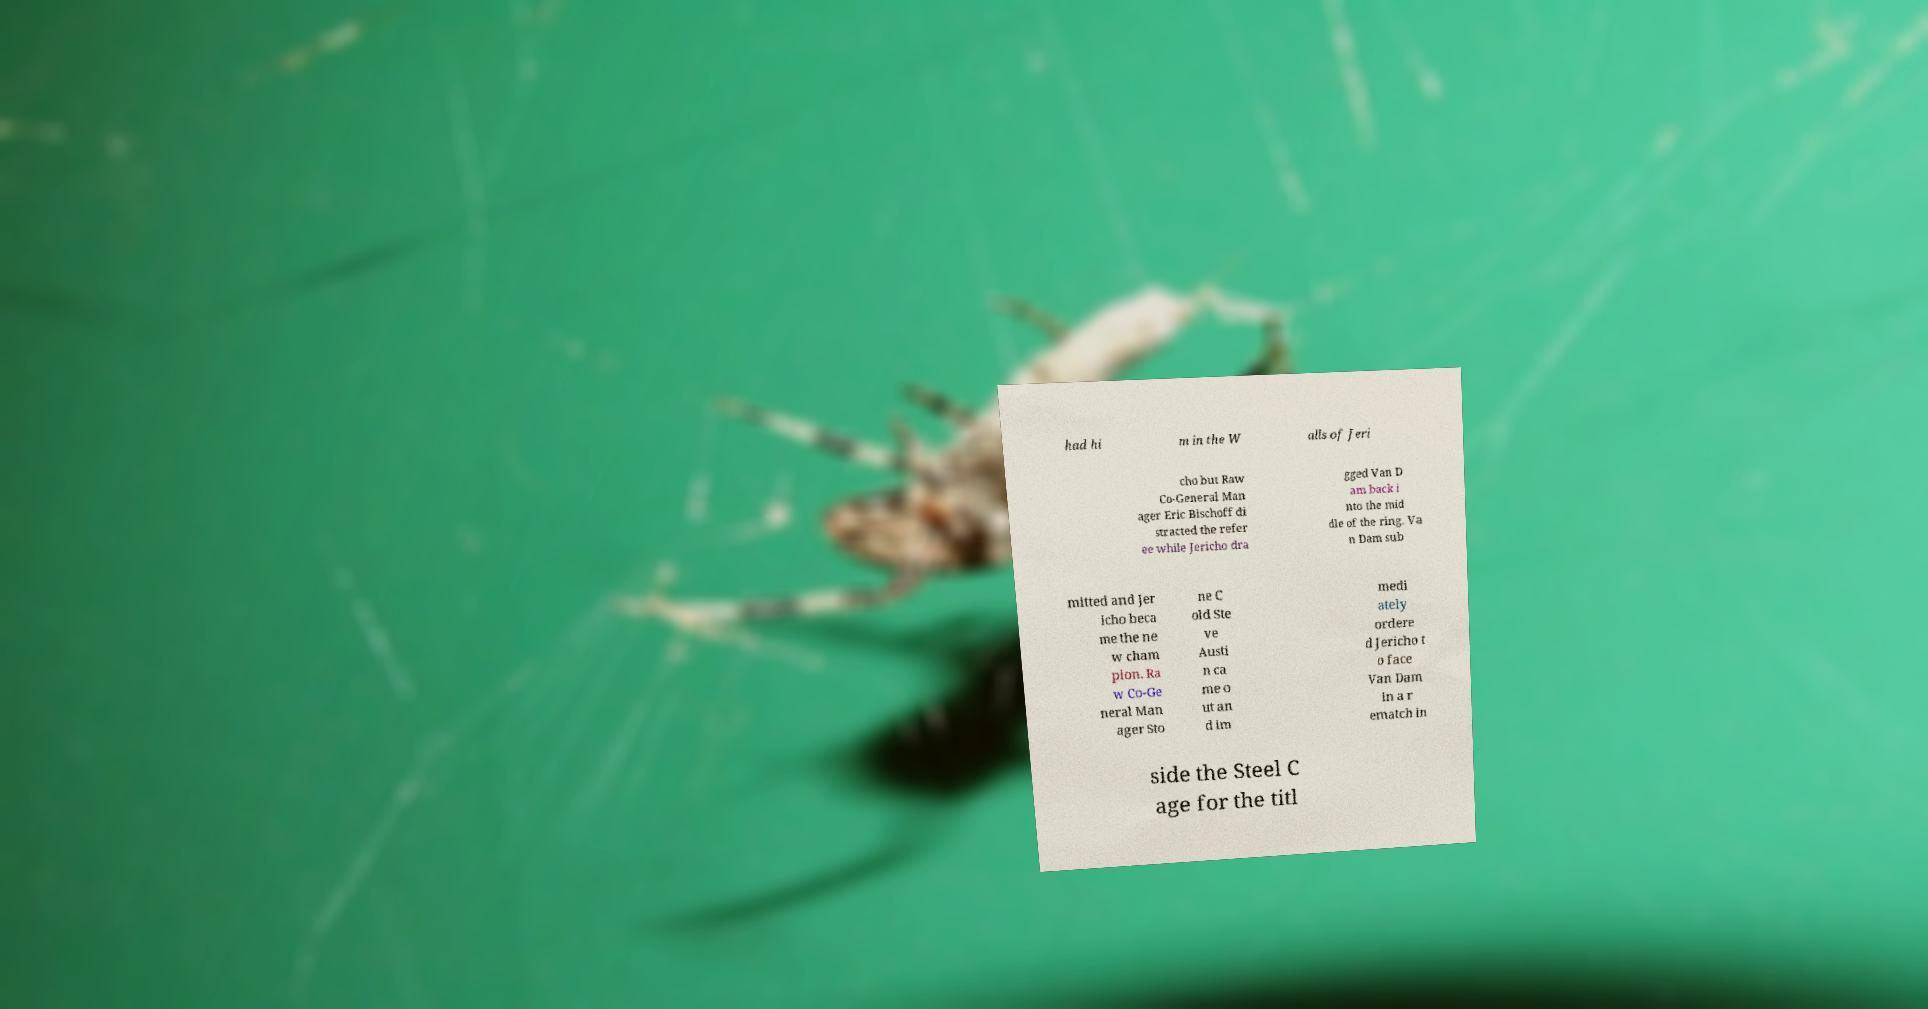For documentation purposes, I need the text within this image transcribed. Could you provide that? had hi m in the W alls of Jeri cho but Raw Co-General Man ager Eric Bischoff di stracted the refer ee while Jericho dra gged Van D am back i nto the mid dle of the ring. Va n Dam sub mitted and Jer icho beca me the ne w cham pion. Ra w Co-Ge neral Man ager Sto ne C old Ste ve Austi n ca me o ut an d im medi ately ordere d Jericho t o face Van Dam in a r ematch in side the Steel C age for the titl 